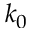Convert formula to latex. <formula><loc_0><loc_0><loc_500><loc_500>k _ { 0 }</formula> 